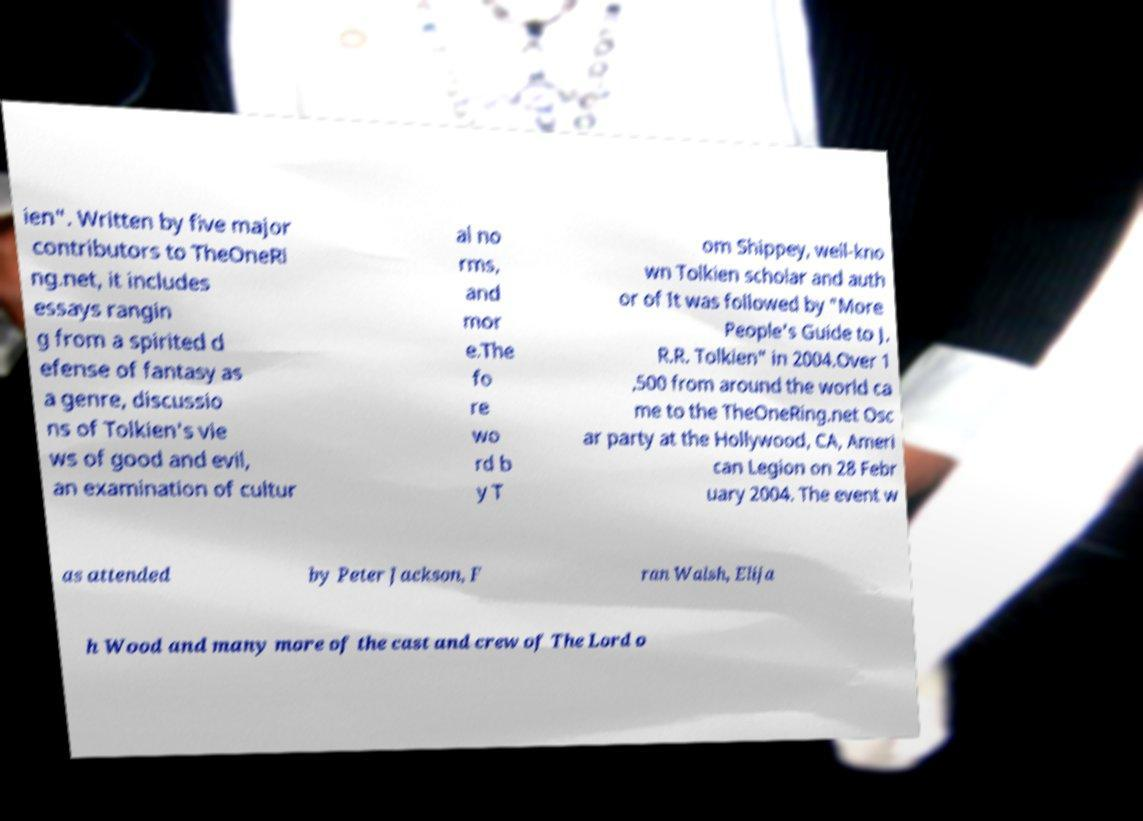I need the written content from this picture converted into text. Can you do that? ien". Written by five major contributors to TheOneRi ng.net, it includes essays rangin g from a spirited d efense of fantasy as a genre, discussio ns of Tolkien's vie ws of good and evil, an examination of cultur al no rms, and mor e.The fo re wo rd b y T om Shippey, well-kno wn Tolkien scholar and auth or of It was followed by "More People's Guide to J. R.R. Tolkien" in 2004.Over 1 ,500 from around the world ca me to the TheOneRing.net Osc ar party at the Hollywood, CA, Ameri can Legion on 28 Febr uary 2004. The event w as attended by Peter Jackson, F ran Walsh, Elija h Wood and many more of the cast and crew of The Lord o 